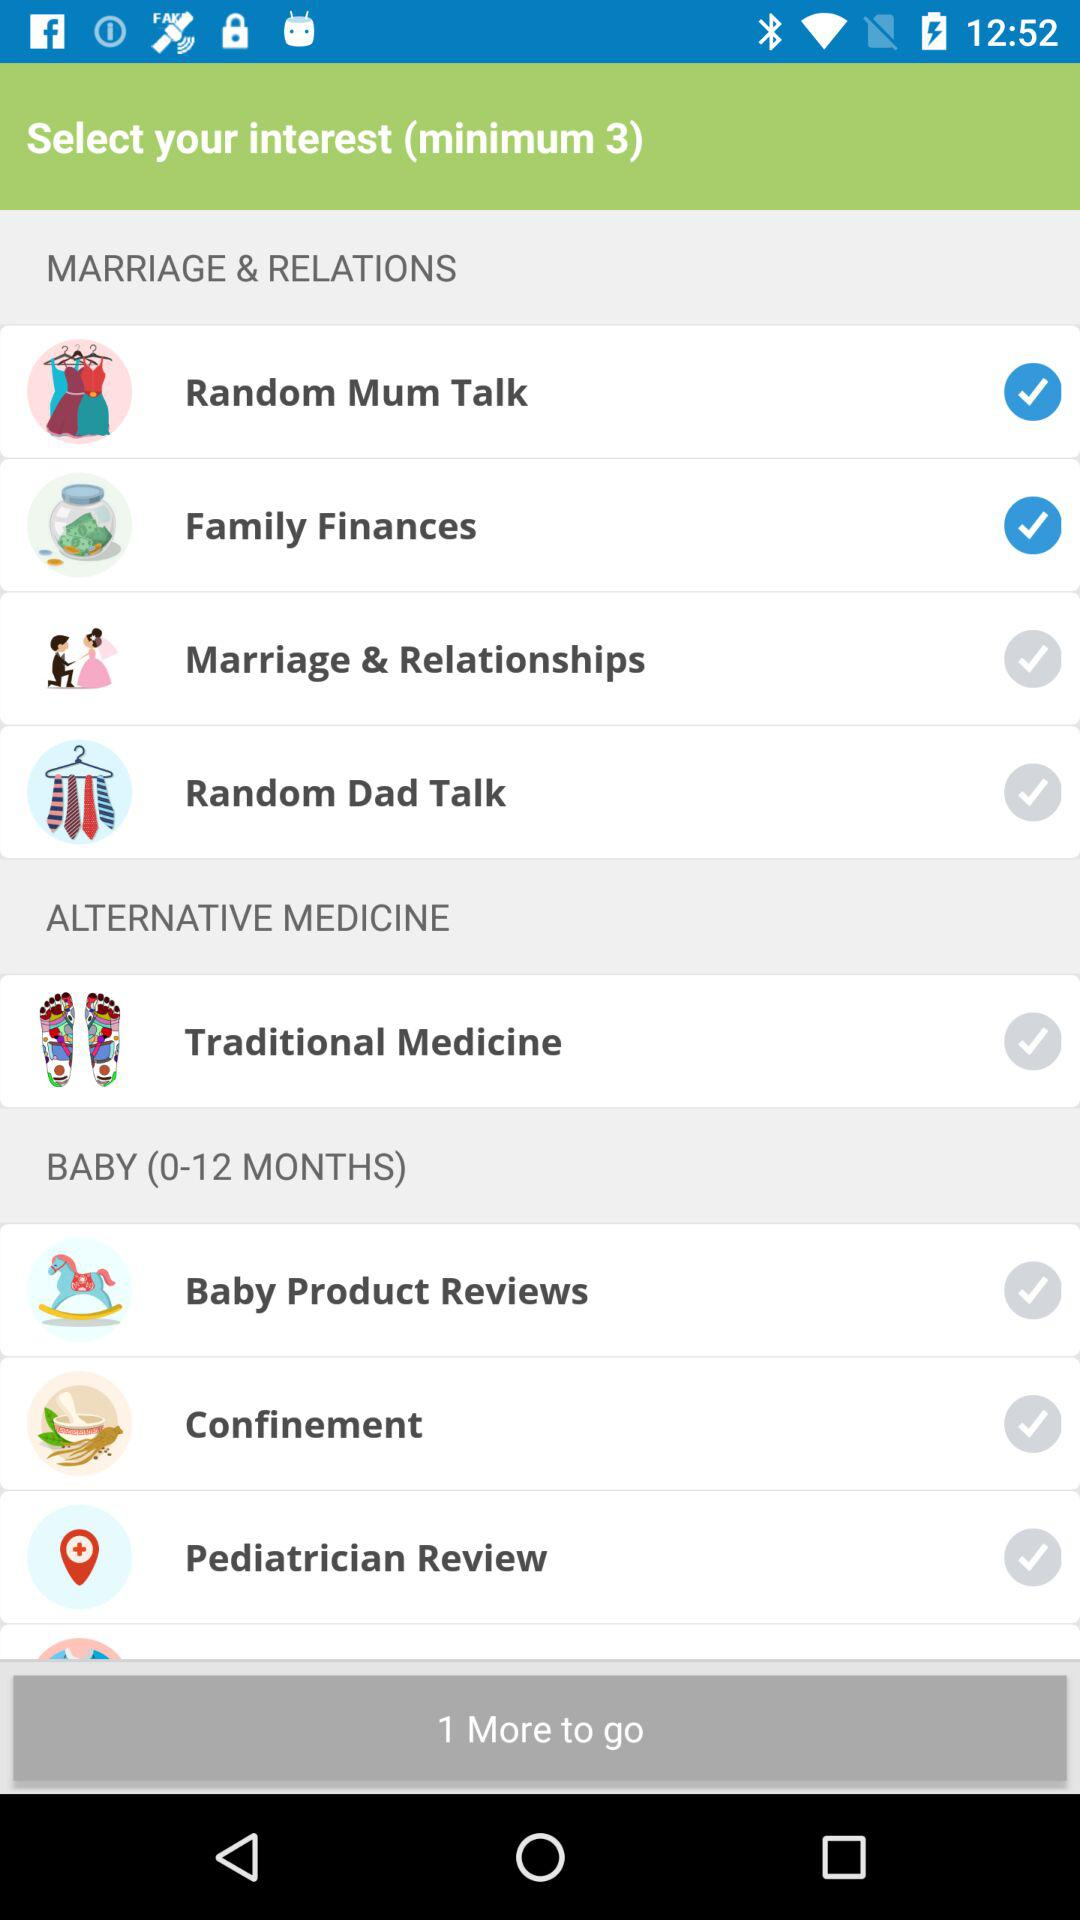What's the selected interest under the "MARRIAGE & RELATIONS" category? The selected interests under the "MARRIAGE & RELATIONS" category are "Random Mum Talk" and "Family Finances". 